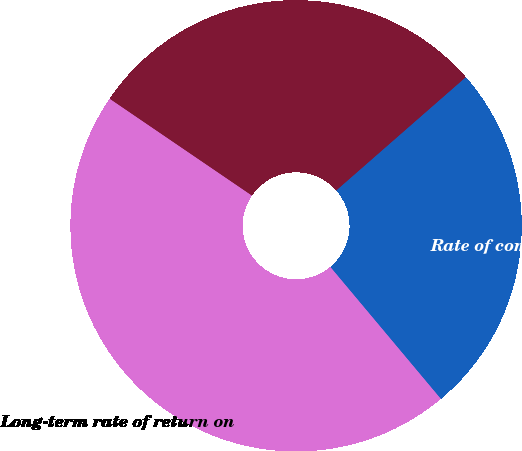Convert chart to OTSL. <chart><loc_0><loc_0><loc_500><loc_500><pie_chart><fcel>Discount rate<fcel>Long-term rate of return on<fcel>Rate of compensation increase<nl><fcel>29.05%<fcel>45.61%<fcel>25.34%<nl></chart> 